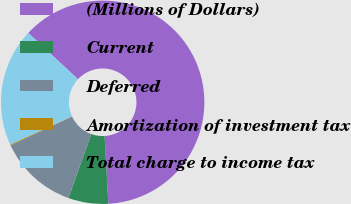Convert chart. <chart><loc_0><loc_0><loc_500><loc_500><pie_chart><fcel>(Millions of Dollars)<fcel>Current<fcel>Deferred<fcel>Amortization of investment tax<fcel>Total charge to income tax<nl><fcel>62.17%<fcel>6.36%<fcel>12.56%<fcel>0.15%<fcel>18.76%<nl></chart> 